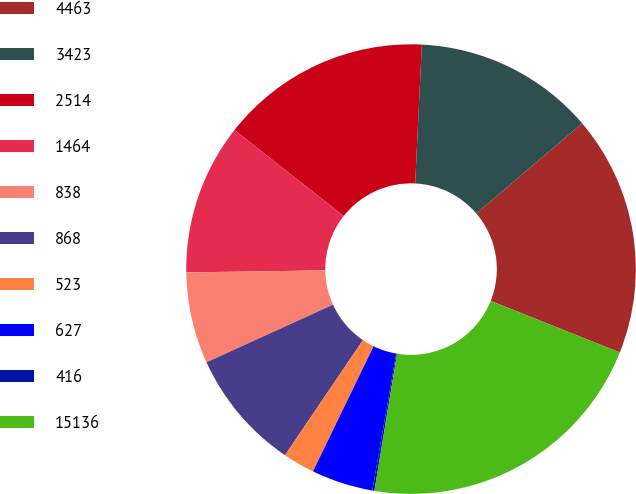Convert chart to OTSL. <chart><loc_0><loc_0><loc_500><loc_500><pie_chart><fcel>4463<fcel>3423<fcel>2514<fcel>1464<fcel>838<fcel>868<fcel>523<fcel>627<fcel>416<fcel>15136<nl><fcel>17.28%<fcel>13.0%<fcel>15.14%<fcel>10.86%<fcel>6.57%<fcel>8.72%<fcel>2.29%<fcel>4.43%<fcel>0.15%<fcel>21.56%<nl></chart> 